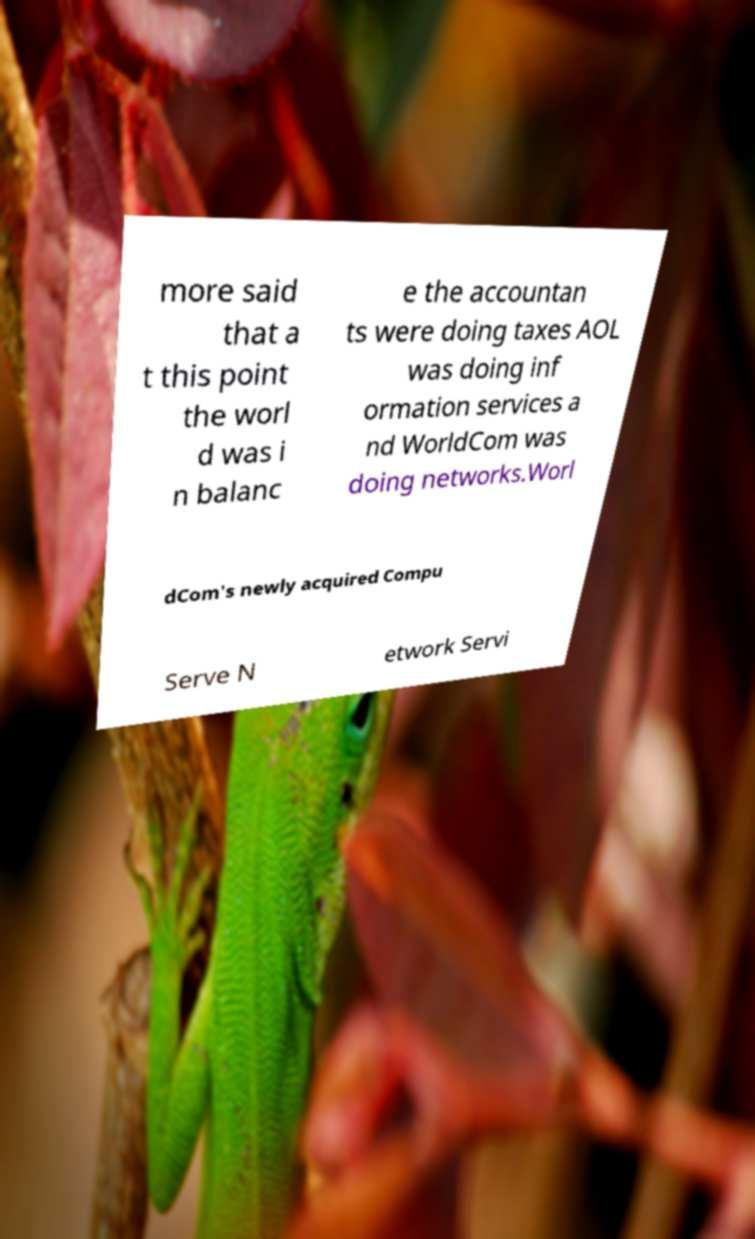Please identify and transcribe the text found in this image. more said that a t this point the worl d was i n balanc e the accountan ts were doing taxes AOL was doing inf ormation services a nd WorldCom was doing networks.Worl dCom's newly acquired Compu Serve N etwork Servi 